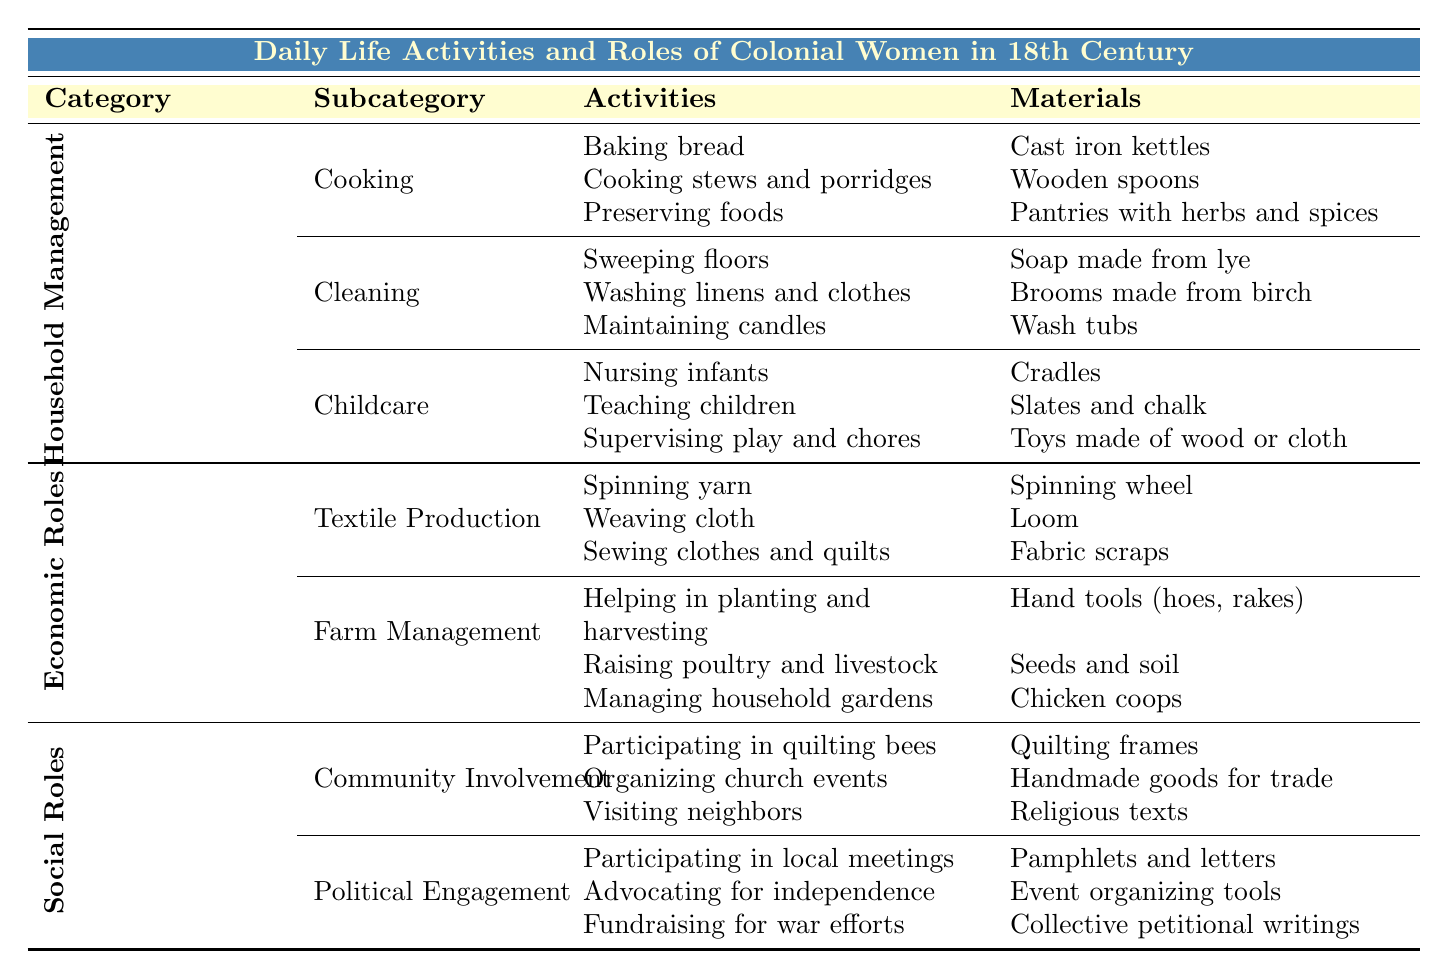What activities are involved in the Cooking subcategory of Household Management? The Cooking subcategory lists three specific activities: baking bread, cooking stews and porridges, and preserving foods. These activities are explicitly mentioned in the table under the Cooking section.
Answer: Baking bread, cooking stews and porridges, preserving foods What materials are used for Cleaning tasks? The Cleaning section of the table specifies three materials associated with cleaning: soap made from lye, brooms made from birch, and wash tubs. These materials are listed directly under the Cleaning activities.
Answer: Soap made from lye, brooms made from birch, wash tubs Are women involved in Political Engagement activities? Yes, the table clearly mentions that women participated in political engagement activities such as participating in local meetings, advocating for independence, and fundraising for war efforts. Therefore, this statement is true.
Answer: Yes How many total activities are listed under Economic Roles? There are two subcategories under Economic Roles: Textile Production and Farm Management. Each subcategory has three activities, so the total number of activities is 3 (Textile Production) + 3 (Farm Management) = 6.
Answer: 6 What is the relationship between Community Involvement and the materials used? The Community Involvement subcategory includes activities like participating in quilting bees, organizing church events, and visiting neighbors. The materials listed for these activities include quilting frames, handmade goods for trade, and religious texts. This indicates that community activities rely on specific materials that assist in social interaction and organization.
Answer: Community activities rely on specific materials How many activities focus on Childcare compared to Cooking? In Childcare, there are three activities listed: nursing infants, teaching children basic education, and supervising play and chores. In Cooking, there are also three activities: baking bread, cooking stews and porridges, and preserving foods. Both activities have the same number.
Answer: Equal number (3 each) What are the common materials used in both Household Management and Economic Roles? Household Management materials predominantly feature household items (e.g., cast iron kettles, soap) whereas Economic Roles focus on production tools (e.g., spinning wheel, hand tools). There is no common material between these two broad categories as they serve different purposes.
Answer: None Which aspect of daily life involves raising poultry and livestock? The activities of raising poultry and livestock fall under the Farm Management subcategory, which is part of Economic Roles. This involves specific tasks related to agriculture, demonstrating women’s contributions to economic sustenance.
Answer: Farm Management Can you summarize the connection between the activities in Textile Production and their materials? In Textile Production, activities such as spinning yarn, weaving cloth, and sewing involve the use of specific materials: a spinning wheel for spinning, a loom for weaving, and fabric scraps for sewing. Therefore, the connection shows that each activity is inherently tied to the corresponding material needed to perform it effectively.
Answer: Activities depend on specific materials 